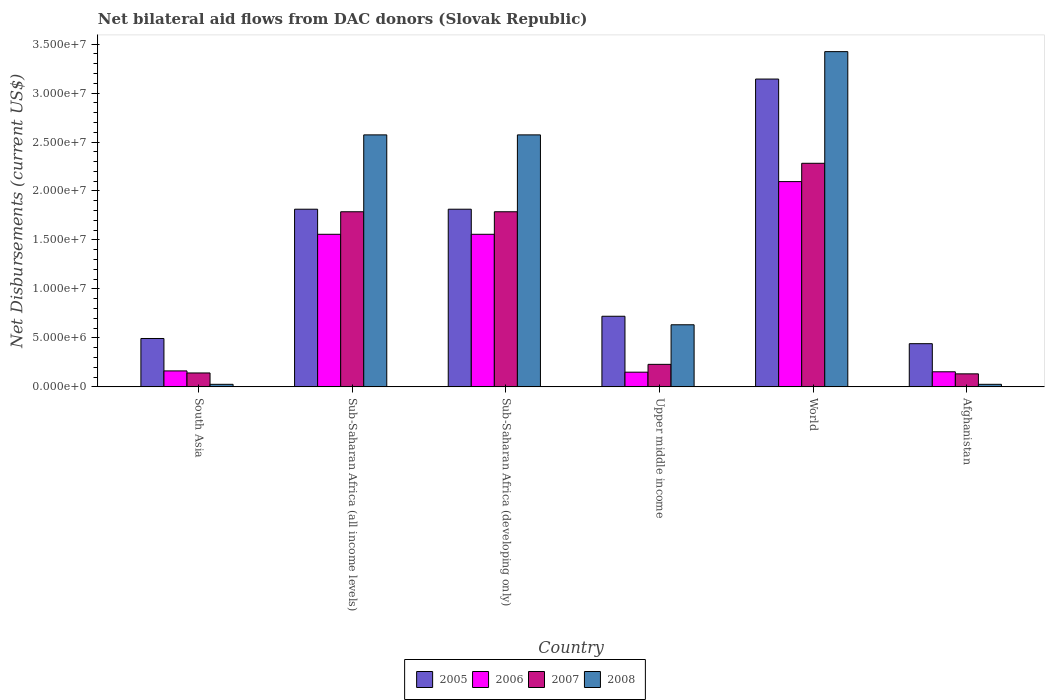How many groups of bars are there?
Keep it short and to the point. 6. How many bars are there on the 5th tick from the left?
Give a very brief answer. 4. What is the label of the 2nd group of bars from the left?
Offer a terse response. Sub-Saharan Africa (all income levels). What is the net bilateral aid flows in 2007 in World?
Provide a succinct answer. 2.28e+07. Across all countries, what is the maximum net bilateral aid flows in 2008?
Keep it short and to the point. 3.42e+07. Across all countries, what is the minimum net bilateral aid flows in 2005?
Your answer should be compact. 4.41e+06. In which country was the net bilateral aid flows in 2007 maximum?
Provide a succinct answer. World. What is the total net bilateral aid flows in 2005 in the graph?
Provide a succinct answer. 8.43e+07. What is the difference between the net bilateral aid flows in 2008 in Afghanistan and that in South Asia?
Your answer should be very brief. 0. What is the difference between the net bilateral aid flows in 2008 in Afghanistan and the net bilateral aid flows in 2006 in Sub-Saharan Africa (developing only)?
Provide a short and direct response. -1.53e+07. What is the average net bilateral aid flows in 2006 per country?
Offer a very short reply. 9.46e+06. What is the ratio of the net bilateral aid flows in 2006 in Upper middle income to that in World?
Offer a terse response. 0.07. Is the net bilateral aid flows in 2007 in Sub-Saharan Africa (all income levels) less than that in Upper middle income?
Make the answer very short. No. What is the difference between the highest and the second highest net bilateral aid flows in 2007?
Provide a short and direct response. 4.95e+06. What is the difference between the highest and the lowest net bilateral aid flows in 2007?
Your answer should be compact. 2.15e+07. Is it the case that in every country, the sum of the net bilateral aid flows in 2005 and net bilateral aid flows in 2006 is greater than the sum of net bilateral aid flows in 2007 and net bilateral aid flows in 2008?
Provide a succinct answer. No. What does the 3rd bar from the left in Sub-Saharan Africa (all income levels) represents?
Offer a very short reply. 2007. What does the 1st bar from the right in Sub-Saharan Africa (all income levels) represents?
Keep it short and to the point. 2008. How many bars are there?
Make the answer very short. 24. How many countries are there in the graph?
Make the answer very short. 6. What is the difference between two consecutive major ticks on the Y-axis?
Your answer should be compact. 5.00e+06. Does the graph contain any zero values?
Your answer should be compact. No. Where does the legend appear in the graph?
Your answer should be compact. Bottom center. How many legend labels are there?
Provide a succinct answer. 4. What is the title of the graph?
Your response must be concise. Net bilateral aid flows from DAC donors (Slovak Republic). Does "2014" appear as one of the legend labels in the graph?
Give a very brief answer. No. What is the label or title of the X-axis?
Offer a terse response. Country. What is the label or title of the Y-axis?
Your answer should be compact. Net Disbursements (current US$). What is the Net Disbursements (current US$) in 2005 in South Asia?
Your answer should be very brief. 4.94e+06. What is the Net Disbursements (current US$) in 2006 in South Asia?
Keep it short and to the point. 1.63e+06. What is the Net Disbursements (current US$) in 2007 in South Asia?
Make the answer very short. 1.42e+06. What is the Net Disbursements (current US$) of 2008 in South Asia?
Your response must be concise. 2.60e+05. What is the Net Disbursements (current US$) in 2005 in Sub-Saharan Africa (all income levels)?
Offer a terse response. 1.81e+07. What is the Net Disbursements (current US$) of 2006 in Sub-Saharan Africa (all income levels)?
Make the answer very short. 1.56e+07. What is the Net Disbursements (current US$) of 2007 in Sub-Saharan Africa (all income levels)?
Make the answer very short. 1.79e+07. What is the Net Disbursements (current US$) of 2008 in Sub-Saharan Africa (all income levels)?
Offer a very short reply. 2.57e+07. What is the Net Disbursements (current US$) in 2005 in Sub-Saharan Africa (developing only)?
Give a very brief answer. 1.81e+07. What is the Net Disbursements (current US$) of 2006 in Sub-Saharan Africa (developing only)?
Ensure brevity in your answer.  1.56e+07. What is the Net Disbursements (current US$) of 2007 in Sub-Saharan Africa (developing only)?
Your response must be concise. 1.79e+07. What is the Net Disbursements (current US$) in 2008 in Sub-Saharan Africa (developing only)?
Provide a succinct answer. 2.57e+07. What is the Net Disbursements (current US$) in 2005 in Upper middle income?
Provide a succinct answer. 7.21e+06. What is the Net Disbursements (current US$) in 2006 in Upper middle income?
Give a very brief answer. 1.50e+06. What is the Net Disbursements (current US$) in 2007 in Upper middle income?
Ensure brevity in your answer.  2.30e+06. What is the Net Disbursements (current US$) in 2008 in Upper middle income?
Your answer should be compact. 6.34e+06. What is the Net Disbursements (current US$) in 2005 in World?
Your answer should be very brief. 3.14e+07. What is the Net Disbursements (current US$) in 2006 in World?
Your answer should be very brief. 2.10e+07. What is the Net Disbursements (current US$) in 2007 in World?
Ensure brevity in your answer.  2.28e+07. What is the Net Disbursements (current US$) in 2008 in World?
Offer a terse response. 3.42e+07. What is the Net Disbursements (current US$) in 2005 in Afghanistan?
Your answer should be very brief. 4.41e+06. What is the Net Disbursements (current US$) in 2006 in Afghanistan?
Make the answer very short. 1.54e+06. What is the Net Disbursements (current US$) in 2007 in Afghanistan?
Your answer should be compact. 1.33e+06. What is the Net Disbursements (current US$) in 2008 in Afghanistan?
Your answer should be compact. 2.60e+05. Across all countries, what is the maximum Net Disbursements (current US$) in 2005?
Provide a short and direct response. 3.14e+07. Across all countries, what is the maximum Net Disbursements (current US$) in 2006?
Offer a very short reply. 2.10e+07. Across all countries, what is the maximum Net Disbursements (current US$) of 2007?
Provide a short and direct response. 2.28e+07. Across all countries, what is the maximum Net Disbursements (current US$) in 2008?
Provide a succinct answer. 3.42e+07. Across all countries, what is the minimum Net Disbursements (current US$) of 2005?
Your response must be concise. 4.41e+06. Across all countries, what is the minimum Net Disbursements (current US$) of 2006?
Keep it short and to the point. 1.50e+06. Across all countries, what is the minimum Net Disbursements (current US$) in 2007?
Offer a terse response. 1.33e+06. Across all countries, what is the minimum Net Disbursements (current US$) of 2008?
Keep it short and to the point. 2.60e+05. What is the total Net Disbursements (current US$) of 2005 in the graph?
Make the answer very short. 8.43e+07. What is the total Net Disbursements (current US$) of 2006 in the graph?
Offer a terse response. 5.68e+07. What is the total Net Disbursements (current US$) of 2007 in the graph?
Provide a short and direct response. 6.36e+07. What is the total Net Disbursements (current US$) of 2008 in the graph?
Your response must be concise. 9.26e+07. What is the difference between the Net Disbursements (current US$) in 2005 in South Asia and that in Sub-Saharan Africa (all income levels)?
Provide a short and direct response. -1.32e+07. What is the difference between the Net Disbursements (current US$) of 2006 in South Asia and that in Sub-Saharan Africa (all income levels)?
Your response must be concise. -1.40e+07. What is the difference between the Net Disbursements (current US$) in 2007 in South Asia and that in Sub-Saharan Africa (all income levels)?
Your answer should be very brief. -1.65e+07. What is the difference between the Net Disbursements (current US$) of 2008 in South Asia and that in Sub-Saharan Africa (all income levels)?
Ensure brevity in your answer.  -2.55e+07. What is the difference between the Net Disbursements (current US$) in 2005 in South Asia and that in Sub-Saharan Africa (developing only)?
Your answer should be compact. -1.32e+07. What is the difference between the Net Disbursements (current US$) of 2006 in South Asia and that in Sub-Saharan Africa (developing only)?
Make the answer very short. -1.40e+07. What is the difference between the Net Disbursements (current US$) in 2007 in South Asia and that in Sub-Saharan Africa (developing only)?
Your answer should be very brief. -1.65e+07. What is the difference between the Net Disbursements (current US$) of 2008 in South Asia and that in Sub-Saharan Africa (developing only)?
Give a very brief answer. -2.55e+07. What is the difference between the Net Disbursements (current US$) of 2005 in South Asia and that in Upper middle income?
Give a very brief answer. -2.27e+06. What is the difference between the Net Disbursements (current US$) of 2007 in South Asia and that in Upper middle income?
Provide a short and direct response. -8.80e+05. What is the difference between the Net Disbursements (current US$) in 2008 in South Asia and that in Upper middle income?
Your answer should be very brief. -6.08e+06. What is the difference between the Net Disbursements (current US$) of 2005 in South Asia and that in World?
Provide a short and direct response. -2.65e+07. What is the difference between the Net Disbursements (current US$) of 2006 in South Asia and that in World?
Keep it short and to the point. -1.93e+07. What is the difference between the Net Disbursements (current US$) in 2007 in South Asia and that in World?
Your answer should be compact. -2.14e+07. What is the difference between the Net Disbursements (current US$) in 2008 in South Asia and that in World?
Keep it short and to the point. -3.40e+07. What is the difference between the Net Disbursements (current US$) in 2005 in South Asia and that in Afghanistan?
Keep it short and to the point. 5.30e+05. What is the difference between the Net Disbursements (current US$) of 2008 in South Asia and that in Afghanistan?
Provide a succinct answer. 0. What is the difference between the Net Disbursements (current US$) of 2005 in Sub-Saharan Africa (all income levels) and that in Sub-Saharan Africa (developing only)?
Your response must be concise. 0. What is the difference between the Net Disbursements (current US$) of 2006 in Sub-Saharan Africa (all income levels) and that in Sub-Saharan Africa (developing only)?
Ensure brevity in your answer.  0. What is the difference between the Net Disbursements (current US$) of 2008 in Sub-Saharan Africa (all income levels) and that in Sub-Saharan Africa (developing only)?
Offer a very short reply. 0. What is the difference between the Net Disbursements (current US$) of 2005 in Sub-Saharan Africa (all income levels) and that in Upper middle income?
Provide a short and direct response. 1.09e+07. What is the difference between the Net Disbursements (current US$) in 2006 in Sub-Saharan Africa (all income levels) and that in Upper middle income?
Keep it short and to the point. 1.41e+07. What is the difference between the Net Disbursements (current US$) in 2007 in Sub-Saharan Africa (all income levels) and that in Upper middle income?
Provide a succinct answer. 1.56e+07. What is the difference between the Net Disbursements (current US$) in 2008 in Sub-Saharan Africa (all income levels) and that in Upper middle income?
Offer a terse response. 1.94e+07. What is the difference between the Net Disbursements (current US$) in 2005 in Sub-Saharan Africa (all income levels) and that in World?
Your answer should be very brief. -1.33e+07. What is the difference between the Net Disbursements (current US$) in 2006 in Sub-Saharan Africa (all income levels) and that in World?
Provide a short and direct response. -5.38e+06. What is the difference between the Net Disbursements (current US$) of 2007 in Sub-Saharan Africa (all income levels) and that in World?
Make the answer very short. -4.95e+06. What is the difference between the Net Disbursements (current US$) in 2008 in Sub-Saharan Africa (all income levels) and that in World?
Keep it short and to the point. -8.50e+06. What is the difference between the Net Disbursements (current US$) of 2005 in Sub-Saharan Africa (all income levels) and that in Afghanistan?
Your answer should be compact. 1.37e+07. What is the difference between the Net Disbursements (current US$) in 2006 in Sub-Saharan Africa (all income levels) and that in Afghanistan?
Your answer should be compact. 1.40e+07. What is the difference between the Net Disbursements (current US$) of 2007 in Sub-Saharan Africa (all income levels) and that in Afghanistan?
Give a very brief answer. 1.66e+07. What is the difference between the Net Disbursements (current US$) of 2008 in Sub-Saharan Africa (all income levels) and that in Afghanistan?
Provide a short and direct response. 2.55e+07. What is the difference between the Net Disbursements (current US$) in 2005 in Sub-Saharan Africa (developing only) and that in Upper middle income?
Ensure brevity in your answer.  1.09e+07. What is the difference between the Net Disbursements (current US$) in 2006 in Sub-Saharan Africa (developing only) and that in Upper middle income?
Your answer should be compact. 1.41e+07. What is the difference between the Net Disbursements (current US$) in 2007 in Sub-Saharan Africa (developing only) and that in Upper middle income?
Provide a short and direct response. 1.56e+07. What is the difference between the Net Disbursements (current US$) of 2008 in Sub-Saharan Africa (developing only) and that in Upper middle income?
Offer a very short reply. 1.94e+07. What is the difference between the Net Disbursements (current US$) of 2005 in Sub-Saharan Africa (developing only) and that in World?
Your answer should be very brief. -1.33e+07. What is the difference between the Net Disbursements (current US$) of 2006 in Sub-Saharan Africa (developing only) and that in World?
Your answer should be very brief. -5.38e+06. What is the difference between the Net Disbursements (current US$) in 2007 in Sub-Saharan Africa (developing only) and that in World?
Your response must be concise. -4.95e+06. What is the difference between the Net Disbursements (current US$) in 2008 in Sub-Saharan Africa (developing only) and that in World?
Provide a succinct answer. -8.50e+06. What is the difference between the Net Disbursements (current US$) of 2005 in Sub-Saharan Africa (developing only) and that in Afghanistan?
Provide a succinct answer. 1.37e+07. What is the difference between the Net Disbursements (current US$) of 2006 in Sub-Saharan Africa (developing only) and that in Afghanistan?
Provide a short and direct response. 1.40e+07. What is the difference between the Net Disbursements (current US$) in 2007 in Sub-Saharan Africa (developing only) and that in Afghanistan?
Keep it short and to the point. 1.66e+07. What is the difference between the Net Disbursements (current US$) of 2008 in Sub-Saharan Africa (developing only) and that in Afghanistan?
Give a very brief answer. 2.55e+07. What is the difference between the Net Disbursements (current US$) of 2005 in Upper middle income and that in World?
Ensure brevity in your answer.  -2.42e+07. What is the difference between the Net Disbursements (current US$) in 2006 in Upper middle income and that in World?
Your answer should be compact. -1.95e+07. What is the difference between the Net Disbursements (current US$) of 2007 in Upper middle income and that in World?
Your response must be concise. -2.05e+07. What is the difference between the Net Disbursements (current US$) of 2008 in Upper middle income and that in World?
Your answer should be compact. -2.79e+07. What is the difference between the Net Disbursements (current US$) in 2005 in Upper middle income and that in Afghanistan?
Offer a terse response. 2.80e+06. What is the difference between the Net Disbursements (current US$) in 2006 in Upper middle income and that in Afghanistan?
Your answer should be compact. -4.00e+04. What is the difference between the Net Disbursements (current US$) of 2007 in Upper middle income and that in Afghanistan?
Your answer should be very brief. 9.70e+05. What is the difference between the Net Disbursements (current US$) of 2008 in Upper middle income and that in Afghanistan?
Your answer should be very brief. 6.08e+06. What is the difference between the Net Disbursements (current US$) of 2005 in World and that in Afghanistan?
Make the answer very short. 2.70e+07. What is the difference between the Net Disbursements (current US$) of 2006 in World and that in Afghanistan?
Your answer should be very brief. 1.94e+07. What is the difference between the Net Disbursements (current US$) in 2007 in World and that in Afghanistan?
Make the answer very short. 2.15e+07. What is the difference between the Net Disbursements (current US$) of 2008 in World and that in Afghanistan?
Your answer should be very brief. 3.40e+07. What is the difference between the Net Disbursements (current US$) in 2005 in South Asia and the Net Disbursements (current US$) in 2006 in Sub-Saharan Africa (all income levels)?
Keep it short and to the point. -1.06e+07. What is the difference between the Net Disbursements (current US$) of 2005 in South Asia and the Net Disbursements (current US$) of 2007 in Sub-Saharan Africa (all income levels)?
Your answer should be compact. -1.29e+07. What is the difference between the Net Disbursements (current US$) of 2005 in South Asia and the Net Disbursements (current US$) of 2008 in Sub-Saharan Africa (all income levels)?
Provide a short and direct response. -2.08e+07. What is the difference between the Net Disbursements (current US$) in 2006 in South Asia and the Net Disbursements (current US$) in 2007 in Sub-Saharan Africa (all income levels)?
Make the answer very short. -1.62e+07. What is the difference between the Net Disbursements (current US$) in 2006 in South Asia and the Net Disbursements (current US$) in 2008 in Sub-Saharan Africa (all income levels)?
Provide a succinct answer. -2.41e+07. What is the difference between the Net Disbursements (current US$) of 2007 in South Asia and the Net Disbursements (current US$) of 2008 in Sub-Saharan Africa (all income levels)?
Make the answer very short. -2.43e+07. What is the difference between the Net Disbursements (current US$) of 2005 in South Asia and the Net Disbursements (current US$) of 2006 in Sub-Saharan Africa (developing only)?
Give a very brief answer. -1.06e+07. What is the difference between the Net Disbursements (current US$) of 2005 in South Asia and the Net Disbursements (current US$) of 2007 in Sub-Saharan Africa (developing only)?
Keep it short and to the point. -1.29e+07. What is the difference between the Net Disbursements (current US$) of 2005 in South Asia and the Net Disbursements (current US$) of 2008 in Sub-Saharan Africa (developing only)?
Provide a short and direct response. -2.08e+07. What is the difference between the Net Disbursements (current US$) in 2006 in South Asia and the Net Disbursements (current US$) in 2007 in Sub-Saharan Africa (developing only)?
Your answer should be compact. -1.62e+07. What is the difference between the Net Disbursements (current US$) in 2006 in South Asia and the Net Disbursements (current US$) in 2008 in Sub-Saharan Africa (developing only)?
Provide a succinct answer. -2.41e+07. What is the difference between the Net Disbursements (current US$) of 2007 in South Asia and the Net Disbursements (current US$) of 2008 in Sub-Saharan Africa (developing only)?
Offer a very short reply. -2.43e+07. What is the difference between the Net Disbursements (current US$) of 2005 in South Asia and the Net Disbursements (current US$) of 2006 in Upper middle income?
Your answer should be very brief. 3.44e+06. What is the difference between the Net Disbursements (current US$) in 2005 in South Asia and the Net Disbursements (current US$) in 2007 in Upper middle income?
Your answer should be compact. 2.64e+06. What is the difference between the Net Disbursements (current US$) of 2005 in South Asia and the Net Disbursements (current US$) of 2008 in Upper middle income?
Offer a very short reply. -1.40e+06. What is the difference between the Net Disbursements (current US$) in 2006 in South Asia and the Net Disbursements (current US$) in 2007 in Upper middle income?
Make the answer very short. -6.70e+05. What is the difference between the Net Disbursements (current US$) of 2006 in South Asia and the Net Disbursements (current US$) of 2008 in Upper middle income?
Your answer should be very brief. -4.71e+06. What is the difference between the Net Disbursements (current US$) of 2007 in South Asia and the Net Disbursements (current US$) of 2008 in Upper middle income?
Ensure brevity in your answer.  -4.92e+06. What is the difference between the Net Disbursements (current US$) of 2005 in South Asia and the Net Disbursements (current US$) of 2006 in World?
Make the answer very short. -1.60e+07. What is the difference between the Net Disbursements (current US$) of 2005 in South Asia and the Net Disbursements (current US$) of 2007 in World?
Make the answer very short. -1.79e+07. What is the difference between the Net Disbursements (current US$) of 2005 in South Asia and the Net Disbursements (current US$) of 2008 in World?
Provide a short and direct response. -2.93e+07. What is the difference between the Net Disbursements (current US$) of 2006 in South Asia and the Net Disbursements (current US$) of 2007 in World?
Offer a very short reply. -2.12e+07. What is the difference between the Net Disbursements (current US$) of 2006 in South Asia and the Net Disbursements (current US$) of 2008 in World?
Ensure brevity in your answer.  -3.26e+07. What is the difference between the Net Disbursements (current US$) of 2007 in South Asia and the Net Disbursements (current US$) of 2008 in World?
Provide a succinct answer. -3.28e+07. What is the difference between the Net Disbursements (current US$) in 2005 in South Asia and the Net Disbursements (current US$) in 2006 in Afghanistan?
Your answer should be very brief. 3.40e+06. What is the difference between the Net Disbursements (current US$) of 2005 in South Asia and the Net Disbursements (current US$) of 2007 in Afghanistan?
Your answer should be compact. 3.61e+06. What is the difference between the Net Disbursements (current US$) in 2005 in South Asia and the Net Disbursements (current US$) in 2008 in Afghanistan?
Your response must be concise. 4.68e+06. What is the difference between the Net Disbursements (current US$) in 2006 in South Asia and the Net Disbursements (current US$) in 2007 in Afghanistan?
Ensure brevity in your answer.  3.00e+05. What is the difference between the Net Disbursements (current US$) of 2006 in South Asia and the Net Disbursements (current US$) of 2008 in Afghanistan?
Keep it short and to the point. 1.37e+06. What is the difference between the Net Disbursements (current US$) of 2007 in South Asia and the Net Disbursements (current US$) of 2008 in Afghanistan?
Keep it short and to the point. 1.16e+06. What is the difference between the Net Disbursements (current US$) in 2005 in Sub-Saharan Africa (all income levels) and the Net Disbursements (current US$) in 2006 in Sub-Saharan Africa (developing only)?
Make the answer very short. 2.56e+06. What is the difference between the Net Disbursements (current US$) in 2005 in Sub-Saharan Africa (all income levels) and the Net Disbursements (current US$) in 2008 in Sub-Saharan Africa (developing only)?
Your answer should be compact. -7.59e+06. What is the difference between the Net Disbursements (current US$) in 2006 in Sub-Saharan Africa (all income levels) and the Net Disbursements (current US$) in 2007 in Sub-Saharan Africa (developing only)?
Provide a short and direct response. -2.30e+06. What is the difference between the Net Disbursements (current US$) in 2006 in Sub-Saharan Africa (all income levels) and the Net Disbursements (current US$) in 2008 in Sub-Saharan Africa (developing only)?
Offer a terse response. -1.02e+07. What is the difference between the Net Disbursements (current US$) of 2007 in Sub-Saharan Africa (all income levels) and the Net Disbursements (current US$) of 2008 in Sub-Saharan Africa (developing only)?
Your response must be concise. -7.85e+06. What is the difference between the Net Disbursements (current US$) of 2005 in Sub-Saharan Africa (all income levels) and the Net Disbursements (current US$) of 2006 in Upper middle income?
Offer a very short reply. 1.66e+07. What is the difference between the Net Disbursements (current US$) in 2005 in Sub-Saharan Africa (all income levels) and the Net Disbursements (current US$) in 2007 in Upper middle income?
Give a very brief answer. 1.58e+07. What is the difference between the Net Disbursements (current US$) of 2005 in Sub-Saharan Africa (all income levels) and the Net Disbursements (current US$) of 2008 in Upper middle income?
Make the answer very short. 1.18e+07. What is the difference between the Net Disbursements (current US$) in 2006 in Sub-Saharan Africa (all income levels) and the Net Disbursements (current US$) in 2007 in Upper middle income?
Your answer should be very brief. 1.33e+07. What is the difference between the Net Disbursements (current US$) in 2006 in Sub-Saharan Africa (all income levels) and the Net Disbursements (current US$) in 2008 in Upper middle income?
Offer a very short reply. 9.24e+06. What is the difference between the Net Disbursements (current US$) of 2007 in Sub-Saharan Africa (all income levels) and the Net Disbursements (current US$) of 2008 in Upper middle income?
Provide a short and direct response. 1.15e+07. What is the difference between the Net Disbursements (current US$) of 2005 in Sub-Saharan Africa (all income levels) and the Net Disbursements (current US$) of 2006 in World?
Give a very brief answer. -2.82e+06. What is the difference between the Net Disbursements (current US$) of 2005 in Sub-Saharan Africa (all income levels) and the Net Disbursements (current US$) of 2007 in World?
Your answer should be very brief. -4.69e+06. What is the difference between the Net Disbursements (current US$) in 2005 in Sub-Saharan Africa (all income levels) and the Net Disbursements (current US$) in 2008 in World?
Provide a succinct answer. -1.61e+07. What is the difference between the Net Disbursements (current US$) of 2006 in Sub-Saharan Africa (all income levels) and the Net Disbursements (current US$) of 2007 in World?
Offer a very short reply. -7.25e+06. What is the difference between the Net Disbursements (current US$) in 2006 in Sub-Saharan Africa (all income levels) and the Net Disbursements (current US$) in 2008 in World?
Give a very brief answer. -1.86e+07. What is the difference between the Net Disbursements (current US$) in 2007 in Sub-Saharan Africa (all income levels) and the Net Disbursements (current US$) in 2008 in World?
Your answer should be very brief. -1.64e+07. What is the difference between the Net Disbursements (current US$) of 2005 in Sub-Saharan Africa (all income levels) and the Net Disbursements (current US$) of 2006 in Afghanistan?
Offer a very short reply. 1.66e+07. What is the difference between the Net Disbursements (current US$) in 2005 in Sub-Saharan Africa (all income levels) and the Net Disbursements (current US$) in 2007 in Afghanistan?
Ensure brevity in your answer.  1.68e+07. What is the difference between the Net Disbursements (current US$) in 2005 in Sub-Saharan Africa (all income levels) and the Net Disbursements (current US$) in 2008 in Afghanistan?
Offer a terse response. 1.79e+07. What is the difference between the Net Disbursements (current US$) of 2006 in Sub-Saharan Africa (all income levels) and the Net Disbursements (current US$) of 2007 in Afghanistan?
Keep it short and to the point. 1.42e+07. What is the difference between the Net Disbursements (current US$) of 2006 in Sub-Saharan Africa (all income levels) and the Net Disbursements (current US$) of 2008 in Afghanistan?
Give a very brief answer. 1.53e+07. What is the difference between the Net Disbursements (current US$) of 2007 in Sub-Saharan Africa (all income levels) and the Net Disbursements (current US$) of 2008 in Afghanistan?
Your answer should be very brief. 1.76e+07. What is the difference between the Net Disbursements (current US$) of 2005 in Sub-Saharan Africa (developing only) and the Net Disbursements (current US$) of 2006 in Upper middle income?
Offer a very short reply. 1.66e+07. What is the difference between the Net Disbursements (current US$) of 2005 in Sub-Saharan Africa (developing only) and the Net Disbursements (current US$) of 2007 in Upper middle income?
Give a very brief answer. 1.58e+07. What is the difference between the Net Disbursements (current US$) of 2005 in Sub-Saharan Africa (developing only) and the Net Disbursements (current US$) of 2008 in Upper middle income?
Keep it short and to the point. 1.18e+07. What is the difference between the Net Disbursements (current US$) in 2006 in Sub-Saharan Africa (developing only) and the Net Disbursements (current US$) in 2007 in Upper middle income?
Your answer should be compact. 1.33e+07. What is the difference between the Net Disbursements (current US$) of 2006 in Sub-Saharan Africa (developing only) and the Net Disbursements (current US$) of 2008 in Upper middle income?
Give a very brief answer. 9.24e+06. What is the difference between the Net Disbursements (current US$) in 2007 in Sub-Saharan Africa (developing only) and the Net Disbursements (current US$) in 2008 in Upper middle income?
Keep it short and to the point. 1.15e+07. What is the difference between the Net Disbursements (current US$) in 2005 in Sub-Saharan Africa (developing only) and the Net Disbursements (current US$) in 2006 in World?
Ensure brevity in your answer.  -2.82e+06. What is the difference between the Net Disbursements (current US$) of 2005 in Sub-Saharan Africa (developing only) and the Net Disbursements (current US$) of 2007 in World?
Your response must be concise. -4.69e+06. What is the difference between the Net Disbursements (current US$) of 2005 in Sub-Saharan Africa (developing only) and the Net Disbursements (current US$) of 2008 in World?
Ensure brevity in your answer.  -1.61e+07. What is the difference between the Net Disbursements (current US$) of 2006 in Sub-Saharan Africa (developing only) and the Net Disbursements (current US$) of 2007 in World?
Offer a very short reply. -7.25e+06. What is the difference between the Net Disbursements (current US$) in 2006 in Sub-Saharan Africa (developing only) and the Net Disbursements (current US$) in 2008 in World?
Provide a short and direct response. -1.86e+07. What is the difference between the Net Disbursements (current US$) of 2007 in Sub-Saharan Africa (developing only) and the Net Disbursements (current US$) of 2008 in World?
Give a very brief answer. -1.64e+07. What is the difference between the Net Disbursements (current US$) of 2005 in Sub-Saharan Africa (developing only) and the Net Disbursements (current US$) of 2006 in Afghanistan?
Give a very brief answer. 1.66e+07. What is the difference between the Net Disbursements (current US$) of 2005 in Sub-Saharan Africa (developing only) and the Net Disbursements (current US$) of 2007 in Afghanistan?
Provide a succinct answer. 1.68e+07. What is the difference between the Net Disbursements (current US$) of 2005 in Sub-Saharan Africa (developing only) and the Net Disbursements (current US$) of 2008 in Afghanistan?
Give a very brief answer. 1.79e+07. What is the difference between the Net Disbursements (current US$) of 2006 in Sub-Saharan Africa (developing only) and the Net Disbursements (current US$) of 2007 in Afghanistan?
Keep it short and to the point. 1.42e+07. What is the difference between the Net Disbursements (current US$) of 2006 in Sub-Saharan Africa (developing only) and the Net Disbursements (current US$) of 2008 in Afghanistan?
Provide a short and direct response. 1.53e+07. What is the difference between the Net Disbursements (current US$) in 2007 in Sub-Saharan Africa (developing only) and the Net Disbursements (current US$) in 2008 in Afghanistan?
Offer a very short reply. 1.76e+07. What is the difference between the Net Disbursements (current US$) in 2005 in Upper middle income and the Net Disbursements (current US$) in 2006 in World?
Keep it short and to the point. -1.38e+07. What is the difference between the Net Disbursements (current US$) of 2005 in Upper middle income and the Net Disbursements (current US$) of 2007 in World?
Provide a short and direct response. -1.56e+07. What is the difference between the Net Disbursements (current US$) in 2005 in Upper middle income and the Net Disbursements (current US$) in 2008 in World?
Give a very brief answer. -2.70e+07. What is the difference between the Net Disbursements (current US$) in 2006 in Upper middle income and the Net Disbursements (current US$) in 2007 in World?
Offer a terse response. -2.13e+07. What is the difference between the Net Disbursements (current US$) of 2006 in Upper middle income and the Net Disbursements (current US$) of 2008 in World?
Offer a very short reply. -3.27e+07. What is the difference between the Net Disbursements (current US$) of 2007 in Upper middle income and the Net Disbursements (current US$) of 2008 in World?
Provide a succinct answer. -3.19e+07. What is the difference between the Net Disbursements (current US$) in 2005 in Upper middle income and the Net Disbursements (current US$) in 2006 in Afghanistan?
Keep it short and to the point. 5.67e+06. What is the difference between the Net Disbursements (current US$) of 2005 in Upper middle income and the Net Disbursements (current US$) of 2007 in Afghanistan?
Offer a very short reply. 5.88e+06. What is the difference between the Net Disbursements (current US$) of 2005 in Upper middle income and the Net Disbursements (current US$) of 2008 in Afghanistan?
Keep it short and to the point. 6.95e+06. What is the difference between the Net Disbursements (current US$) in 2006 in Upper middle income and the Net Disbursements (current US$) in 2008 in Afghanistan?
Give a very brief answer. 1.24e+06. What is the difference between the Net Disbursements (current US$) in 2007 in Upper middle income and the Net Disbursements (current US$) in 2008 in Afghanistan?
Provide a short and direct response. 2.04e+06. What is the difference between the Net Disbursements (current US$) in 2005 in World and the Net Disbursements (current US$) in 2006 in Afghanistan?
Your answer should be very brief. 2.99e+07. What is the difference between the Net Disbursements (current US$) of 2005 in World and the Net Disbursements (current US$) of 2007 in Afghanistan?
Keep it short and to the point. 3.01e+07. What is the difference between the Net Disbursements (current US$) of 2005 in World and the Net Disbursements (current US$) of 2008 in Afghanistan?
Offer a very short reply. 3.12e+07. What is the difference between the Net Disbursements (current US$) in 2006 in World and the Net Disbursements (current US$) in 2007 in Afghanistan?
Offer a very short reply. 1.96e+07. What is the difference between the Net Disbursements (current US$) of 2006 in World and the Net Disbursements (current US$) of 2008 in Afghanistan?
Provide a short and direct response. 2.07e+07. What is the difference between the Net Disbursements (current US$) in 2007 in World and the Net Disbursements (current US$) in 2008 in Afghanistan?
Provide a succinct answer. 2.26e+07. What is the average Net Disbursements (current US$) of 2005 per country?
Your answer should be very brief. 1.40e+07. What is the average Net Disbursements (current US$) in 2006 per country?
Your answer should be compact. 9.46e+06. What is the average Net Disbursements (current US$) in 2007 per country?
Your answer should be compact. 1.06e+07. What is the average Net Disbursements (current US$) of 2008 per country?
Your answer should be very brief. 1.54e+07. What is the difference between the Net Disbursements (current US$) in 2005 and Net Disbursements (current US$) in 2006 in South Asia?
Give a very brief answer. 3.31e+06. What is the difference between the Net Disbursements (current US$) of 2005 and Net Disbursements (current US$) of 2007 in South Asia?
Ensure brevity in your answer.  3.52e+06. What is the difference between the Net Disbursements (current US$) of 2005 and Net Disbursements (current US$) of 2008 in South Asia?
Provide a short and direct response. 4.68e+06. What is the difference between the Net Disbursements (current US$) in 2006 and Net Disbursements (current US$) in 2007 in South Asia?
Ensure brevity in your answer.  2.10e+05. What is the difference between the Net Disbursements (current US$) in 2006 and Net Disbursements (current US$) in 2008 in South Asia?
Offer a very short reply. 1.37e+06. What is the difference between the Net Disbursements (current US$) in 2007 and Net Disbursements (current US$) in 2008 in South Asia?
Provide a short and direct response. 1.16e+06. What is the difference between the Net Disbursements (current US$) of 2005 and Net Disbursements (current US$) of 2006 in Sub-Saharan Africa (all income levels)?
Offer a very short reply. 2.56e+06. What is the difference between the Net Disbursements (current US$) in 2005 and Net Disbursements (current US$) in 2007 in Sub-Saharan Africa (all income levels)?
Ensure brevity in your answer.  2.60e+05. What is the difference between the Net Disbursements (current US$) in 2005 and Net Disbursements (current US$) in 2008 in Sub-Saharan Africa (all income levels)?
Your response must be concise. -7.59e+06. What is the difference between the Net Disbursements (current US$) of 2006 and Net Disbursements (current US$) of 2007 in Sub-Saharan Africa (all income levels)?
Your response must be concise. -2.30e+06. What is the difference between the Net Disbursements (current US$) of 2006 and Net Disbursements (current US$) of 2008 in Sub-Saharan Africa (all income levels)?
Your response must be concise. -1.02e+07. What is the difference between the Net Disbursements (current US$) in 2007 and Net Disbursements (current US$) in 2008 in Sub-Saharan Africa (all income levels)?
Your answer should be compact. -7.85e+06. What is the difference between the Net Disbursements (current US$) in 2005 and Net Disbursements (current US$) in 2006 in Sub-Saharan Africa (developing only)?
Provide a short and direct response. 2.56e+06. What is the difference between the Net Disbursements (current US$) of 2005 and Net Disbursements (current US$) of 2007 in Sub-Saharan Africa (developing only)?
Ensure brevity in your answer.  2.60e+05. What is the difference between the Net Disbursements (current US$) in 2005 and Net Disbursements (current US$) in 2008 in Sub-Saharan Africa (developing only)?
Ensure brevity in your answer.  -7.59e+06. What is the difference between the Net Disbursements (current US$) of 2006 and Net Disbursements (current US$) of 2007 in Sub-Saharan Africa (developing only)?
Give a very brief answer. -2.30e+06. What is the difference between the Net Disbursements (current US$) of 2006 and Net Disbursements (current US$) of 2008 in Sub-Saharan Africa (developing only)?
Offer a very short reply. -1.02e+07. What is the difference between the Net Disbursements (current US$) in 2007 and Net Disbursements (current US$) in 2008 in Sub-Saharan Africa (developing only)?
Your response must be concise. -7.85e+06. What is the difference between the Net Disbursements (current US$) in 2005 and Net Disbursements (current US$) in 2006 in Upper middle income?
Make the answer very short. 5.71e+06. What is the difference between the Net Disbursements (current US$) of 2005 and Net Disbursements (current US$) of 2007 in Upper middle income?
Your answer should be very brief. 4.91e+06. What is the difference between the Net Disbursements (current US$) of 2005 and Net Disbursements (current US$) of 2008 in Upper middle income?
Give a very brief answer. 8.70e+05. What is the difference between the Net Disbursements (current US$) in 2006 and Net Disbursements (current US$) in 2007 in Upper middle income?
Offer a very short reply. -8.00e+05. What is the difference between the Net Disbursements (current US$) in 2006 and Net Disbursements (current US$) in 2008 in Upper middle income?
Your answer should be very brief. -4.84e+06. What is the difference between the Net Disbursements (current US$) in 2007 and Net Disbursements (current US$) in 2008 in Upper middle income?
Offer a very short reply. -4.04e+06. What is the difference between the Net Disbursements (current US$) in 2005 and Net Disbursements (current US$) in 2006 in World?
Make the answer very short. 1.05e+07. What is the difference between the Net Disbursements (current US$) of 2005 and Net Disbursements (current US$) of 2007 in World?
Offer a very short reply. 8.60e+06. What is the difference between the Net Disbursements (current US$) in 2005 and Net Disbursements (current US$) in 2008 in World?
Keep it short and to the point. -2.80e+06. What is the difference between the Net Disbursements (current US$) of 2006 and Net Disbursements (current US$) of 2007 in World?
Your answer should be compact. -1.87e+06. What is the difference between the Net Disbursements (current US$) in 2006 and Net Disbursements (current US$) in 2008 in World?
Make the answer very short. -1.33e+07. What is the difference between the Net Disbursements (current US$) in 2007 and Net Disbursements (current US$) in 2008 in World?
Your response must be concise. -1.14e+07. What is the difference between the Net Disbursements (current US$) of 2005 and Net Disbursements (current US$) of 2006 in Afghanistan?
Give a very brief answer. 2.87e+06. What is the difference between the Net Disbursements (current US$) of 2005 and Net Disbursements (current US$) of 2007 in Afghanistan?
Offer a very short reply. 3.08e+06. What is the difference between the Net Disbursements (current US$) of 2005 and Net Disbursements (current US$) of 2008 in Afghanistan?
Keep it short and to the point. 4.15e+06. What is the difference between the Net Disbursements (current US$) of 2006 and Net Disbursements (current US$) of 2007 in Afghanistan?
Keep it short and to the point. 2.10e+05. What is the difference between the Net Disbursements (current US$) of 2006 and Net Disbursements (current US$) of 2008 in Afghanistan?
Ensure brevity in your answer.  1.28e+06. What is the difference between the Net Disbursements (current US$) of 2007 and Net Disbursements (current US$) of 2008 in Afghanistan?
Ensure brevity in your answer.  1.07e+06. What is the ratio of the Net Disbursements (current US$) in 2005 in South Asia to that in Sub-Saharan Africa (all income levels)?
Offer a very short reply. 0.27. What is the ratio of the Net Disbursements (current US$) in 2006 in South Asia to that in Sub-Saharan Africa (all income levels)?
Provide a succinct answer. 0.1. What is the ratio of the Net Disbursements (current US$) of 2007 in South Asia to that in Sub-Saharan Africa (all income levels)?
Offer a very short reply. 0.08. What is the ratio of the Net Disbursements (current US$) of 2008 in South Asia to that in Sub-Saharan Africa (all income levels)?
Give a very brief answer. 0.01. What is the ratio of the Net Disbursements (current US$) in 2005 in South Asia to that in Sub-Saharan Africa (developing only)?
Ensure brevity in your answer.  0.27. What is the ratio of the Net Disbursements (current US$) in 2006 in South Asia to that in Sub-Saharan Africa (developing only)?
Your answer should be very brief. 0.1. What is the ratio of the Net Disbursements (current US$) of 2007 in South Asia to that in Sub-Saharan Africa (developing only)?
Ensure brevity in your answer.  0.08. What is the ratio of the Net Disbursements (current US$) of 2008 in South Asia to that in Sub-Saharan Africa (developing only)?
Offer a very short reply. 0.01. What is the ratio of the Net Disbursements (current US$) of 2005 in South Asia to that in Upper middle income?
Provide a succinct answer. 0.69. What is the ratio of the Net Disbursements (current US$) in 2006 in South Asia to that in Upper middle income?
Your answer should be compact. 1.09. What is the ratio of the Net Disbursements (current US$) in 2007 in South Asia to that in Upper middle income?
Offer a very short reply. 0.62. What is the ratio of the Net Disbursements (current US$) in 2008 in South Asia to that in Upper middle income?
Your response must be concise. 0.04. What is the ratio of the Net Disbursements (current US$) of 2005 in South Asia to that in World?
Your answer should be very brief. 0.16. What is the ratio of the Net Disbursements (current US$) in 2006 in South Asia to that in World?
Your answer should be compact. 0.08. What is the ratio of the Net Disbursements (current US$) of 2007 in South Asia to that in World?
Your answer should be compact. 0.06. What is the ratio of the Net Disbursements (current US$) of 2008 in South Asia to that in World?
Your answer should be very brief. 0.01. What is the ratio of the Net Disbursements (current US$) of 2005 in South Asia to that in Afghanistan?
Your answer should be very brief. 1.12. What is the ratio of the Net Disbursements (current US$) in 2006 in South Asia to that in Afghanistan?
Provide a succinct answer. 1.06. What is the ratio of the Net Disbursements (current US$) in 2007 in South Asia to that in Afghanistan?
Offer a terse response. 1.07. What is the ratio of the Net Disbursements (current US$) in 2006 in Sub-Saharan Africa (all income levels) to that in Sub-Saharan Africa (developing only)?
Ensure brevity in your answer.  1. What is the ratio of the Net Disbursements (current US$) of 2007 in Sub-Saharan Africa (all income levels) to that in Sub-Saharan Africa (developing only)?
Your answer should be compact. 1. What is the ratio of the Net Disbursements (current US$) of 2005 in Sub-Saharan Africa (all income levels) to that in Upper middle income?
Ensure brevity in your answer.  2.52. What is the ratio of the Net Disbursements (current US$) in 2006 in Sub-Saharan Africa (all income levels) to that in Upper middle income?
Ensure brevity in your answer.  10.39. What is the ratio of the Net Disbursements (current US$) in 2007 in Sub-Saharan Africa (all income levels) to that in Upper middle income?
Your answer should be very brief. 7.77. What is the ratio of the Net Disbursements (current US$) in 2008 in Sub-Saharan Africa (all income levels) to that in Upper middle income?
Your answer should be very brief. 4.06. What is the ratio of the Net Disbursements (current US$) in 2005 in Sub-Saharan Africa (all income levels) to that in World?
Provide a succinct answer. 0.58. What is the ratio of the Net Disbursements (current US$) in 2006 in Sub-Saharan Africa (all income levels) to that in World?
Provide a succinct answer. 0.74. What is the ratio of the Net Disbursements (current US$) in 2007 in Sub-Saharan Africa (all income levels) to that in World?
Offer a terse response. 0.78. What is the ratio of the Net Disbursements (current US$) in 2008 in Sub-Saharan Africa (all income levels) to that in World?
Provide a short and direct response. 0.75. What is the ratio of the Net Disbursements (current US$) in 2005 in Sub-Saharan Africa (all income levels) to that in Afghanistan?
Your answer should be compact. 4.11. What is the ratio of the Net Disbursements (current US$) of 2006 in Sub-Saharan Africa (all income levels) to that in Afghanistan?
Your response must be concise. 10.12. What is the ratio of the Net Disbursements (current US$) of 2007 in Sub-Saharan Africa (all income levels) to that in Afghanistan?
Ensure brevity in your answer.  13.44. What is the ratio of the Net Disbursements (current US$) in 2008 in Sub-Saharan Africa (all income levels) to that in Afghanistan?
Offer a terse response. 98.96. What is the ratio of the Net Disbursements (current US$) in 2005 in Sub-Saharan Africa (developing only) to that in Upper middle income?
Ensure brevity in your answer.  2.52. What is the ratio of the Net Disbursements (current US$) of 2006 in Sub-Saharan Africa (developing only) to that in Upper middle income?
Offer a very short reply. 10.39. What is the ratio of the Net Disbursements (current US$) in 2007 in Sub-Saharan Africa (developing only) to that in Upper middle income?
Offer a very short reply. 7.77. What is the ratio of the Net Disbursements (current US$) of 2008 in Sub-Saharan Africa (developing only) to that in Upper middle income?
Offer a very short reply. 4.06. What is the ratio of the Net Disbursements (current US$) in 2005 in Sub-Saharan Africa (developing only) to that in World?
Make the answer very short. 0.58. What is the ratio of the Net Disbursements (current US$) of 2006 in Sub-Saharan Africa (developing only) to that in World?
Your answer should be compact. 0.74. What is the ratio of the Net Disbursements (current US$) in 2007 in Sub-Saharan Africa (developing only) to that in World?
Provide a short and direct response. 0.78. What is the ratio of the Net Disbursements (current US$) in 2008 in Sub-Saharan Africa (developing only) to that in World?
Give a very brief answer. 0.75. What is the ratio of the Net Disbursements (current US$) of 2005 in Sub-Saharan Africa (developing only) to that in Afghanistan?
Make the answer very short. 4.11. What is the ratio of the Net Disbursements (current US$) in 2006 in Sub-Saharan Africa (developing only) to that in Afghanistan?
Provide a succinct answer. 10.12. What is the ratio of the Net Disbursements (current US$) of 2007 in Sub-Saharan Africa (developing only) to that in Afghanistan?
Provide a succinct answer. 13.44. What is the ratio of the Net Disbursements (current US$) of 2008 in Sub-Saharan Africa (developing only) to that in Afghanistan?
Provide a succinct answer. 98.96. What is the ratio of the Net Disbursements (current US$) in 2005 in Upper middle income to that in World?
Make the answer very short. 0.23. What is the ratio of the Net Disbursements (current US$) of 2006 in Upper middle income to that in World?
Your response must be concise. 0.07. What is the ratio of the Net Disbursements (current US$) of 2007 in Upper middle income to that in World?
Provide a short and direct response. 0.1. What is the ratio of the Net Disbursements (current US$) in 2008 in Upper middle income to that in World?
Provide a succinct answer. 0.19. What is the ratio of the Net Disbursements (current US$) in 2005 in Upper middle income to that in Afghanistan?
Your response must be concise. 1.63. What is the ratio of the Net Disbursements (current US$) in 2006 in Upper middle income to that in Afghanistan?
Provide a short and direct response. 0.97. What is the ratio of the Net Disbursements (current US$) of 2007 in Upper middle income to that in Afghanistan?
Give a very brief answer. 1.73. What is the ratio of the Net Disbursements (current US$) of 2008 in Upper middle income to that in Afghanistan?
Give a very brief answer. 24.38. What is the ratio of the Net Disbursements (current US$) of 2005 in World to that in Afghanistan?
Make the answer very short. 7.13. What is the ratio of the Net Disbursements (current US$) of 2006 in World to that in Afghanistan?
Provide a short and direct response. 13.61. What is the ratio of the Net Disbursements (current US$) of 2007 in World to that in Afghanistan?
Your response must be concise. 17.17. What is the ratio of the Net Disbursements (current US$) in 2008 in World to that in Afghanistan?
Make the answer very short. 131.65. What is the difference between the highest and the second highest Net Disbursements (current US$) in 2005?
Keep it short and to the point. 1.33e+07. What is the difference between the highest and the second highest Net Disbursements (current US$) in 2006?
Your answer should be compact. 5.38e+06. What is the difference between the highest and the second highest Net Disbursements (current US$) of 2007?
Give a very brief answer. 4.95e+06. What is the difference between the highest and the second highest Net Disbursements (current US$) of 2008?
Your answer should be compact. 8.50e+06. What is the difference between the highest and the lowest Net Disbursements (current US$) in 2005?
Give a very brief answer. 2.70e+07. What is the difference between the highest and the lowest Net Disbursements (current US$) of 2006?
Offer a very short reply. 1.95e+07. What is the difference between the highest and the lowest Net Disbursements (current US$) of 2007?
Offer a terse response. 2.15e+07. What is the difference between the highest and the lowest Net Disbursements (current US$) of 2008?
Make the answer very short. 3.40e+07. 